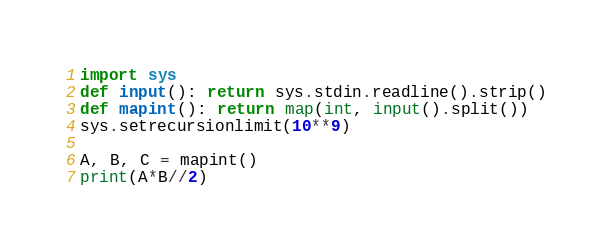<code> <loc_0><loc_0><loc_500><loc_500><_Python_>import sys
def input(): return sys.stdin.readline().strip()
def mapint(): return map(int, input().split())
sys.setrecursionlimit(10**9)

A, B, C = mapint()
print(A*B//2)</code> 